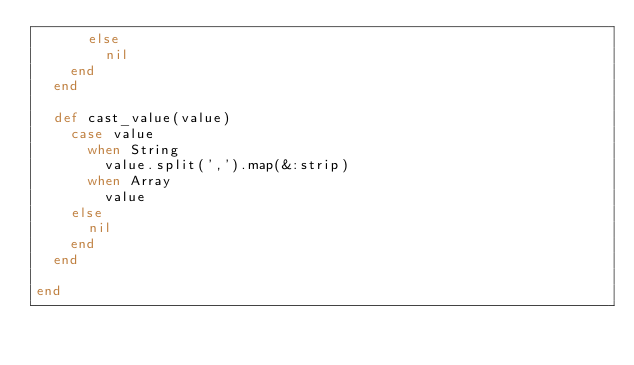Convert code to text. <code><loc_0><loc_0><loc_500><loc_500><_Ruby_>      else
        nil
    end
  end

  def cast_value(value)
    case value
      when String
        value.split(',').map(&:strip)
      when Array
        value
    else
      nil
    end
  end

end</code> 